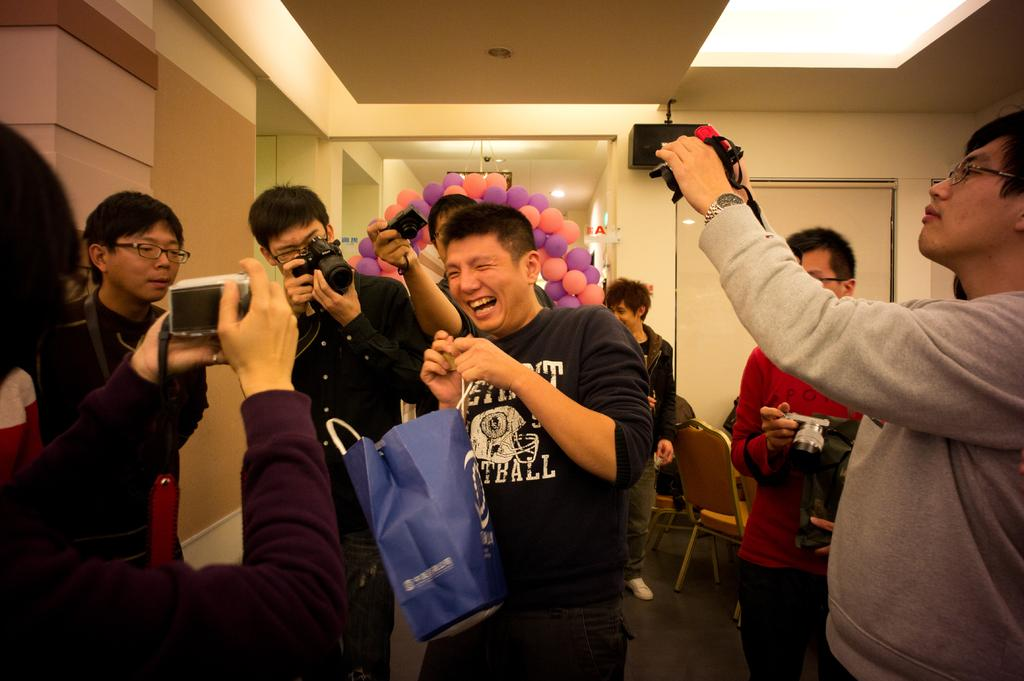What are the people in the image doing? The people in the image are standing and holding cameras. What else can be seen in the image besides the people? There are balloons, chairs, lights, and a wall visible in the image. What type of square is being respected by the people in the image? There is no square or respect-related activity present in the image. Where can the people in the image purchase a store? There is no store present in the image, and the people are not shown purchasing anything. 